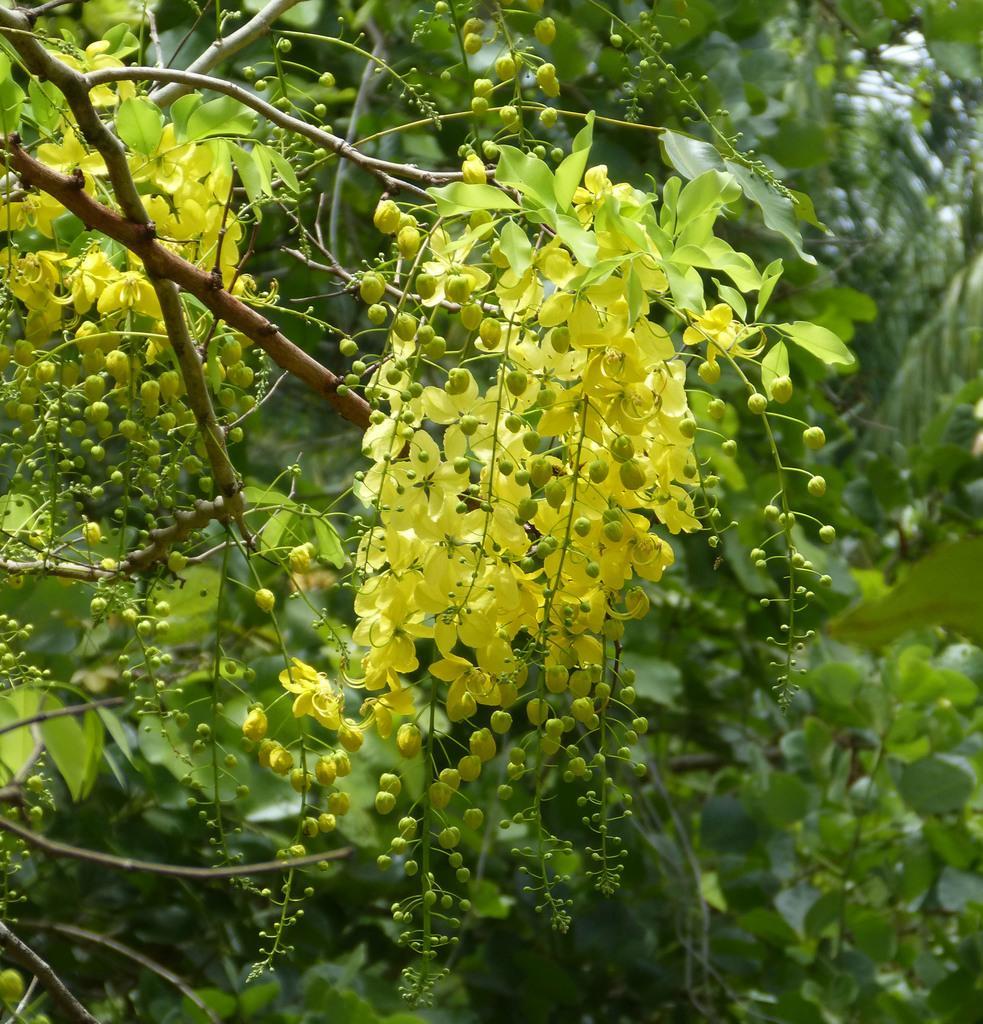How would you summarize this image in a sentence or two? In this image we can see green leaves, stems and buds. 